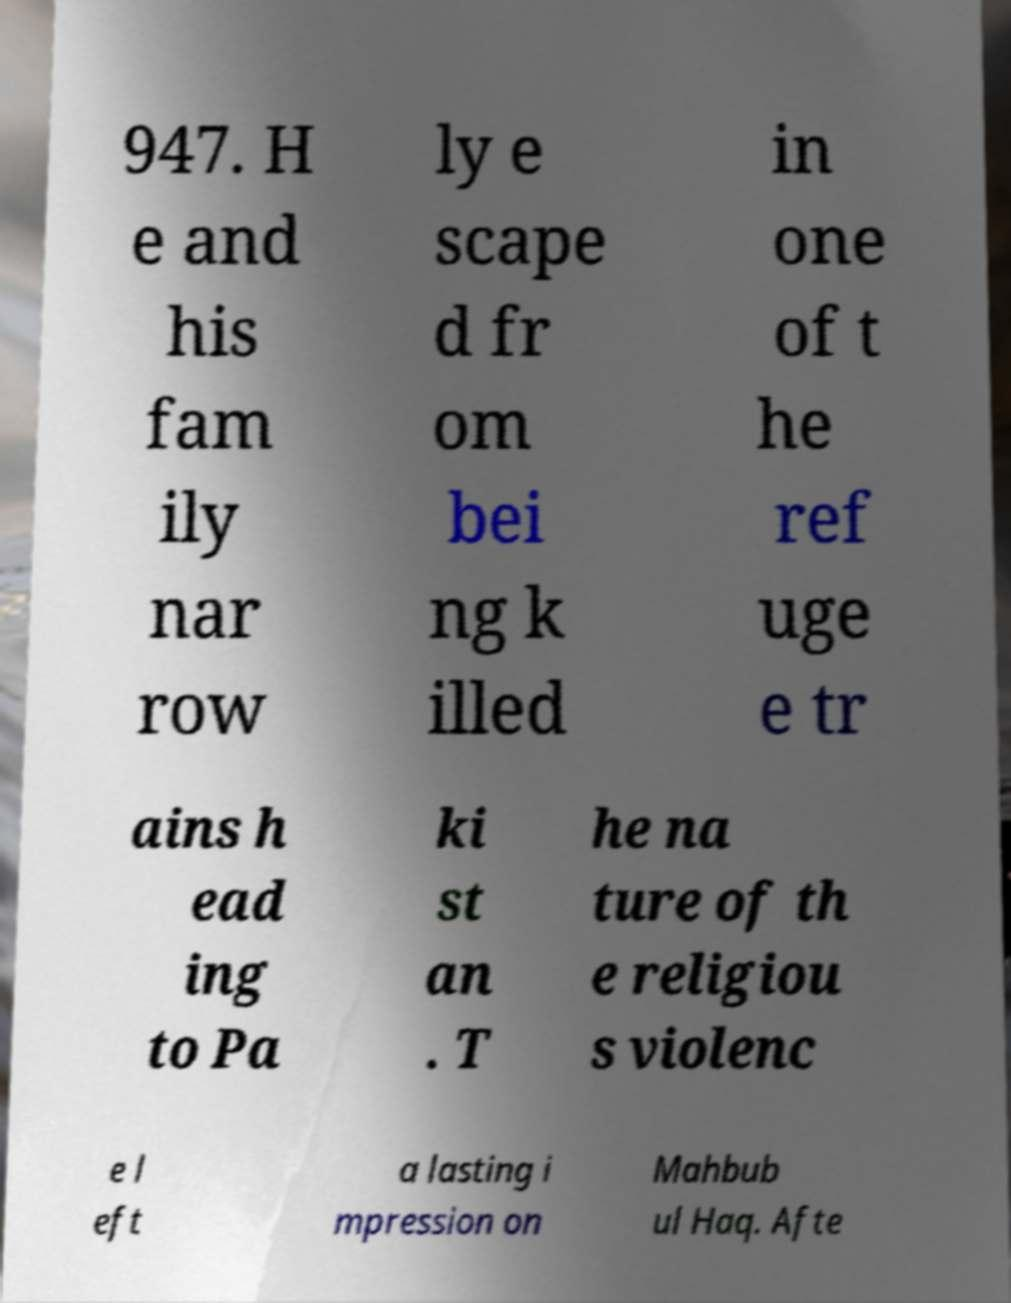Could you extract and type out the text from this image? 947. H e and his fam ily nar row ly e scape d fr om bei ng k illed in one of t he ref uge e tr ains h ead ing to Pa ki st an . T he na ture of th e religiou s violenc e l eft a lasting i mpression on Mahbub ul Haq. Afte 